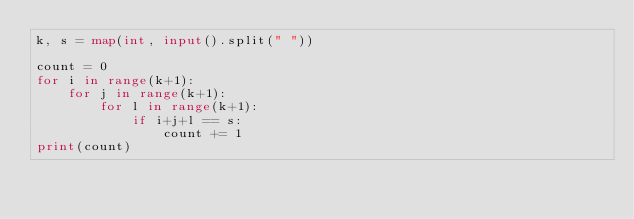<code> <loc_0><loc_0><loc_500><loc_500><_Python_>k, s = map(int, input().split(" "))

count = 0
for i in range(k+1):
    for j in range(k+1):
        for l in range(k+1):
            if i+j+l == s:
                count += 1
print(count)</code> 